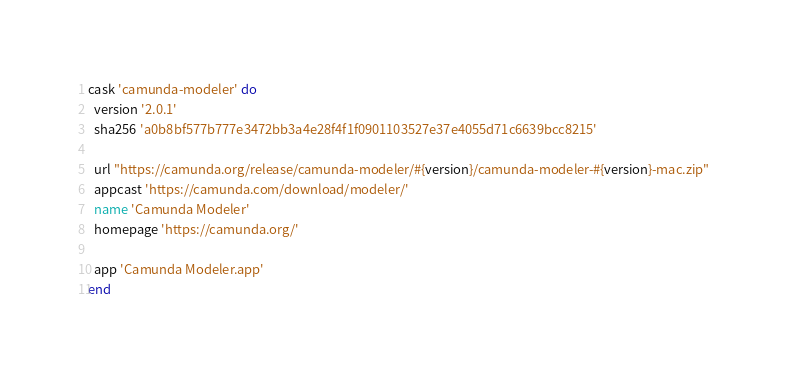Convert code to text. <code><loc_0><loc_0><loc_500><loc_500><_Ruby_>cask 'camunda-modeler' do
  version '2.0.1'
  sha256 'a0b8bf577b777e3472bb3a4e28f4f1f0901103527e37e4055d71c6639bcc8215'

  url "https://camunda.org/release/camunda-modeler/#{version}/camunda-modeler-#{version}-mac.zip"
  appcast 'https://camunda.com/download/modeler/'
  name 'Camunda Modeler'
  homepage 'https://camunda.org/'

  app 'Camunda Modeler.app'
end
</code> 